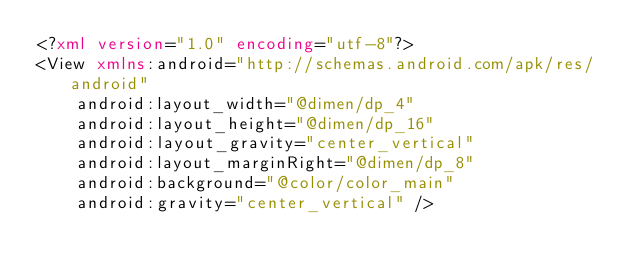<code> <loc_0><loc_0><loc_500><loc_500><_XML_><?xml version="1.0" encoding="utf-8"?>
<View xmlns:android="http://schemas.android.com/apk/res/android"
    android:layout_width="@dimen/dp_4"
    android:layout_height="@dimen/dp_16"
    android:layout_gravity="center_vertical"
    android:layout_marginRight="@dimen/dp_8"
    android:background="@color/color_main"
    android:gravity="center_vertical" /></code> 